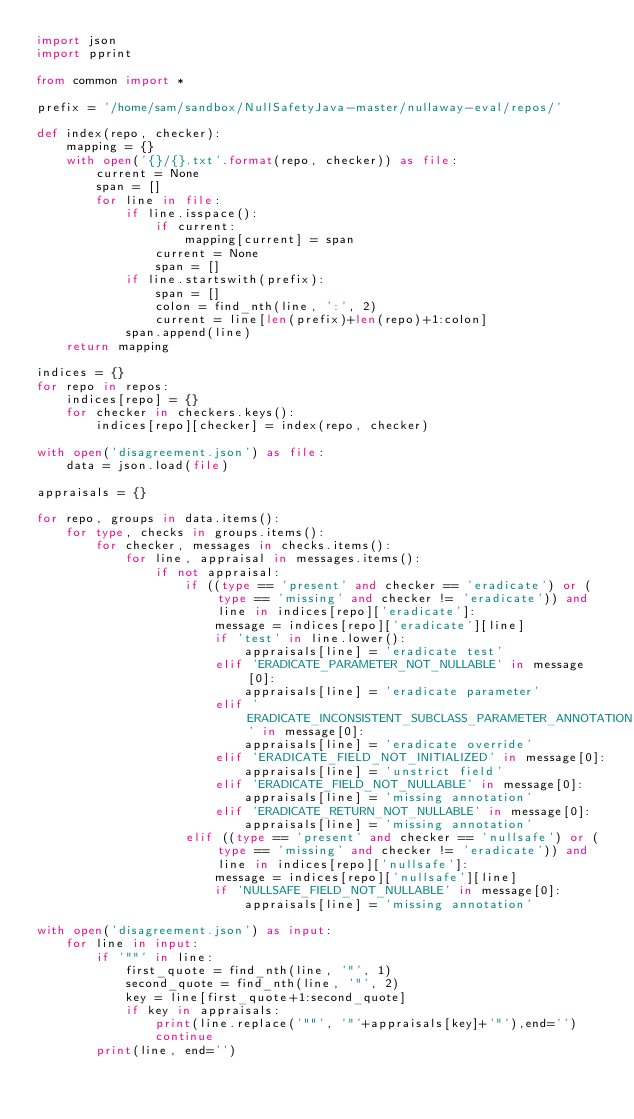Convert code to text. <code><loc_0><loc_0><loc_500><loc_500><_Python_>import json
import pprint

from common import *

prefix = '/home/sam/sandbox/NullSafetyJava-master/nullaway-eval/repos/'

def index(repo, checker):
    mapping = {}
    with open('{}/{}.txt'.format(repo, checker)) as file:
        current = None
        span = []
        for line in file:
            if line.isspace():
                if current:
                    mapping[current] = span
                current = None
                span = []
            if line.startswith(prefix):
                span = []
                colon = find_nth(line, ':', 2)
                current = line[len(prefix)+len(repo)+1:colon]
            span.append(line)
    return mapping

indices = {}
for repo in repos:
    indices[repo] = {}
    for checker in checkers.keys():
        indices[repo][checker] = index(repo, checker)

with open('disagreement.json') as file:
    data = json.load(file)

appraisals = {}

for repo, groups in data.items():
    for type, checks in groups.items():
        for checker, messages in checks.items():
            for line, appraisal in messages.items():
                if not appraisal:
                    if ((type == 'present' and checker == 'eradicate') or (type == 'missing' and checker != 'eradicate')) and line in indices[repo]['eradicate']:
                        message = indices[repo]['eradicate'][line]
                        if 'test' in line.lower():
                            appraisals[line] = 'eradicate test'
                        elif 'ERADICATE_PARAMETER_NOT_NULLABLE' in message[0]:
                            appraisals[line] = 'eradicate parameter'
                        elif 'ERADICATE_INCONSISTENT_SUBCLASS_PARAMETER_ANNOTATION' in message[0]:
                            appraisals[line] = 'eradicate override'
                        elif 'ERADICATE_FIELD_NOT_INITIALIZED' in message[0]:
                            appraisals[line] = 'unstrict field'
                        elif 'ERADICATE_FIELD_NOT_NULLABLE' in message[0]:
                            appraisals[line] = 'missing annotation'
                        elif 'ERADICATE_RETURN_NOT_NULLABLE' in message[0]:
                            appraisals[line] = 'missing annotation'
                    elif ((type == 'present' and checker == 'nullsafe') or (type == 'missing' and checker != 'eradicate')) and line in indices[repo]['nullsafe']:
                        message = indices[repo]['nullsafe'][line]
                        if 'NULLSAFE_FIELD_NOT_NULLABLE' in message[0]:
                            appraisals[line] = 'missing annotation'

with open('disagreement.json') as input:
    for line in input:
        if '""' in line:
            first_quote = find_nth(line, '"', 1)
            second_quote = find_nth(line, '"', 2)
            key = line[first_quote+1:second_quote]
            if key in appraisals:
                print(line.replace('""', '"'+appraisals[key]+'"'),end='')
                continue
        print(line, end='')
</code> 